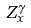<formula> <loc_0><loc_0><loc_500><loc_500>Z _ { x } ^ { \gamma }</formula> 